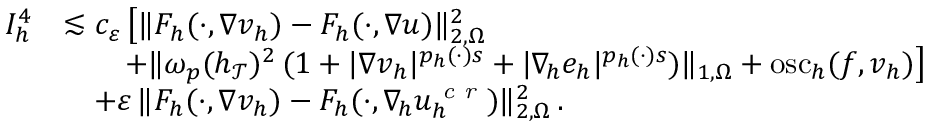<formula> <loc_0><loc_0><loc_500><loc_500>\begin{array} { r } { \begin{array} { r l } { I _ { h } ^ { 4 } } & { \lesssim c _ { \varepsilon } \, \left [ \| F _ { h } ( \cdot , \nabla v _ { h } ) - F _ { h } ( \cdot , \nabla u ) \| _ { 2 , \Omega } ^ { 2 } } \\ & { \quad + \| \omega _ { p } ( h _ { \mathcal { T } } ) ^ { 2 } \, ( 1 + | \nabla v _ { h } | ^ { p _ { h } ( \cdot ) s } + | \nabla _ { \, h } e _ { h } | ^ { p _ { h } ( \cdot ) s } ) \| _ { 1 , \Omega } + o s c _ { h } ( f , v _ { h } ) \right ] } \\ & { \quad + \varepsilon \, \| F _ { h } ( \cdot , \nabla v _ { h } ) - F _ { h } ( \cdot , \nabla _ { \, h } u _ { h } ^ { c r } ) \| _ { 2 , \Omega } ^ { 2 } \, . } \end{array} } \end{array}</formula> 